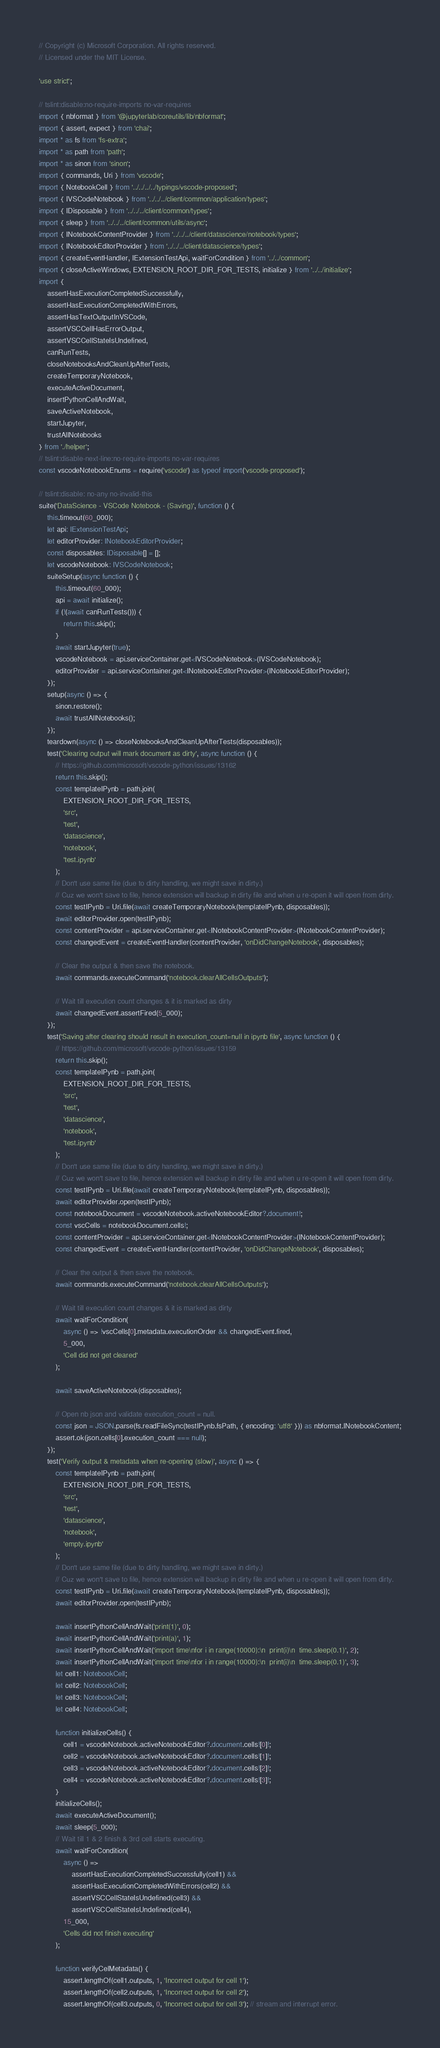Convert code to text. <code><loc_0><loc_0><loc_500><loc_500><_TypeScript_>// Copyright (c) Microsoft Corporation. All rights reserved.
// Licensed under the MIT License.

'use strict';

// tslint:disable:no-require-imports no-var-requires
import { nbformat } from '@jupyterlab/coreutils/lib/nbformat';
import { assert, expect } from 'chai';
import * as fs from 'fs-extra';
import * as path from 'path';
import * as sinon from 'sinon';
import { commands, Uri } from 'vscode';
import { NotebookCell } from '../../../../typings/vscode-proposed';
import { IVSCodeNotebook } from '../../../client/common/application/types';
import { IDisposable } from '../../../client/common/types';
import { sleep } from '../../../client/common/utils/async';
import { INotebookContentProvider } from '../../../client/datascience/notebook/types';
import { INotebookEditorProvider } from '../../../client/datascience/types';
import { createEventHandler, IExtensionTestApi, waitForCondition } from '../../common';
import { closeActiveWindows, EXTENSION_ROOT_DIR_FOR_TESTS, initialize } from '../../initialize';
import {
    assertHasExecutionCompletedSuccessfully,
    assertHasExecutionCompletedWithErrors,
    assertHasTextOutputInVSCode,
    assertVSCCellHasErrorOutput,
    assertVSCCellStateIsUndefined,
    canRunTests,
    closeNotebooksAndCleanUpAfterTests,
    createTemporaryNotebook,
    executeActiveDocument,
    insertPythonCellAndWait,
    saveActiveNotebook,
    startJupyter,
    trustAllNotebooks
} from './helper';
// tslint:disable-next-line:no-require-imports no-var-requires
const vscodeNotebookEnums = require('vscode') as typeof import('vscode-proposed');

// tslint:disable: no-any no-invalid-this
suite('DataScience - VSCode Notebook - (Saving)', function () {
    this.timeout(60_000);
    let api: IExtensionTestApi;
    let editorProvider: INotebookEditorProvider;
    const disposables: IDisposable[] = [];
    let vscodeNotebook: IVSCodeNotebook;
    suiteSetup(async function () {
        this.timeout(60_000);
        api = await initialize();
        if (!(await canRunTests())) {
            return this.skip();
        }
        await startJupyter(true);
        vscodeNotebook = api.serviceContainer.get<IVSCodeNotebook>(IVSCodeNotebook);
        editorProvider = api.serviceContainer.get<INotebookEditorProvider>(INotebookEditorProvider);
    });
    setup(async () => {
        sinon.restore();
        await trustAllNotebooks();
    });
    teardown(async () => closeNotebooksAndCleanUpAfterTests(disposables));
    test('Clearing output will mark document as dirty', async function () {
        // https://github.com/microsoft/vscode-python/issues/13162
        return this.skip();
        const templateIPynb = path.join(
            EXTENSION_ROOT_DIR_FOR_TESTS,
            'src',
            'test',
            'datascience',
            'notebook',
            'test.ipynb'
        );
        // Don't use same file (due to dirty handling, we might save in dirty.)
        // Cuz we won't save to file, hence extension will backup in dirty file and when u re-open it will open from dirty.
        const testIPynb = Uri.file(await createTemporaryNotebook(templateIPynb, disposables));
        await editorProvider.open(testIPynb);
        const contentProvider = api.serviceContainer.get<INotebookContentProvider>(INotebookContentProvider);
        const changedEvent = createEventHandler(contentProvider, 'onDidChangeNotebook', disposables);

        // Clear the output & then save the notebook.
        await commands.executeCommand('notebook.clearAllCellsOutputs');

        // Wait till execution count changes & it is marked as dirty
        await changedEvent.assertFired(5_000);
    });
    test('Saving after clearing should result in execution_count=null in ipynb file', async function () {
        // https://github.com/microsoft/vscode-python/issues/13159
        return this.skip();
        const templateIPynb = path.join(
            EXTENSION_ROOT_DIR_FOR_TESTS,
            'src',
            'test',
            'datascience',
            'notebook',
            'test.ipynb'
        );
        // Don't use same file (due to dirty handling, we might save in dirty.)
        // Cuz we won't save to file, hence extension will backup in dirty file and when u re-open it will open from dirty.
        const testIPynb = Uri.file(await createTemporaryNotebook(templateIPynb, disposables));
        await editorProvider.open(testIPynb);
        const notebookDocument = vscodeNotebook.activeNotebookEditor?.document!;
        const vscCells = notebookDocument.cells!;
        const contentProvider = api.serviceContainer.get<INotebookContentProvider>(INotebookContentProvider);
        const changedEvent = createEventHandler(contentProvider, 'onDidChangeNotebook', disposables);

        // Clear the output & then save the notebook.
        await commands.executeCommand('notebook.clearAllCellsOutputs');

        // Wait till execution count changes & it is marked as dirty
        await waitForCondition(
            async () => !vscCells[0].metadata.executionOrder && changedEvent.fired,
            5_000,
            'Cell did not get cleared'
        );

        await saveActiveNotebook(disposables);

        // Open nb json and validate execution_count = null.
        const json = JSON.parse(fs.readFileSync(testIPynb.fsPath, { encoding: 'utf8' })) as nbformat.INotebookContent;
        assert.ok(json.cells[0].execution_count === null);
    });
    test('Verify output & metadata when re-opening (slow)', async () => {
        const templateIPynb = path.join(
            EXTENSION_ROOT_DIR_FOR_TESTS,
            'src',
            'test',
            'datascience',
            'notebook',
            'empty.ipynb'
        );
        // Don't use same file (due to dirty handling, we might save in dirty.)
        // Cuz we won't save to file, hence extension will backup in dirty file and when u re-open it will open from dirty.
        const testIPynb = Uri.file(await createTemporaryNotebook(templateIPynb, disposables));
        await editorProvider.open(testIPynb);

        await insertPythonCellAndWait('print(1)', 0);
        await insertPythonCellAndWait('print(a)', 1);
        await insertPythonCellAndWait('import time\nfor i in range(10000):\n  print(i)\n  time.sleep(0.1)', 2);
        await insertPythonCellAndWait('import time\nfor i in range(10000):\n  print(i)\n  time.sleep(0.1)', 3);
        let cell1: NotebookCell;
        let cell2: NotebookCell;
        let cell3: NotebookCell;
        let cell4: NotebookCell;

        function initializeCells() {
            cell1 = vscodeNotebook.activeNotebookEditor?.document.cells![0]!;
            cell2 = vscodeNotebook.activeNotebookEditor?.document.cells![1]!;
            cell3 = vscodeNotebook.activeNotebookEditor?.document.cells![2]!;
            cell4 = vscodeNotebook.activeNotebookEditor?.document.cells![3]!;
        }
        initializeCells();
        await executeActiveDocument();
        await sleep(5_000);
        // Wait till 1 & 2 finish & 3rd cell starts executing.
        await waitForCondition(
            async () =>
                assertHasExecutionCompletedSuccessfully(cell1) &&
                assertHasExecutionCompletedWithErrors(cell2) &&
                assertVSCCellStateIsUndefined(cell3) &&
                assertVSCCellStateIsUndefined(cell4),
            15_000,
            'Cells did not finish executing'
        );

        function verifyCelMetadata() {
            assert.lengthOf(cell1.outputs, 1, 'Incorrect output for cell 1');
            assert.lengthOf(cell2.outputs, 1, 'Incorrect output for cell 2');
            assert.lengthOf(cell3.outputs, 0, 'Incorrect output for cell 3'); // stream and interrupt error.</code> 